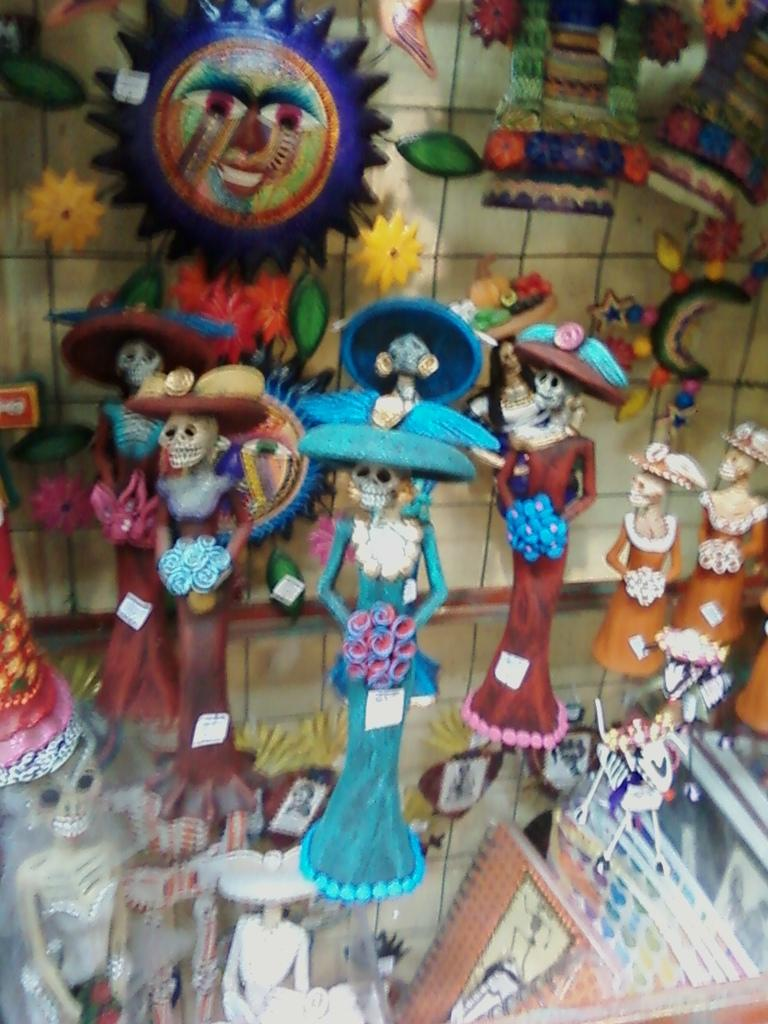What type of objects can be seen in the image? There are toys in the image. What can be seen on the wall in the image? There is a wall with objects attached to it in the image. What type of table is present in the image? There is a glass table in the image. Can you describe any other objects present in the image? There are other objects present in the image, but their specific details are not mentioned in the provided facts. What year is printed on the toys in the image? There is no information about the year or any printing on the toys in the image. What type of metal is used to make the objects attached to the wall? The type of metal used to make the objects attached to the wall is not mentioned in the provided facts. 